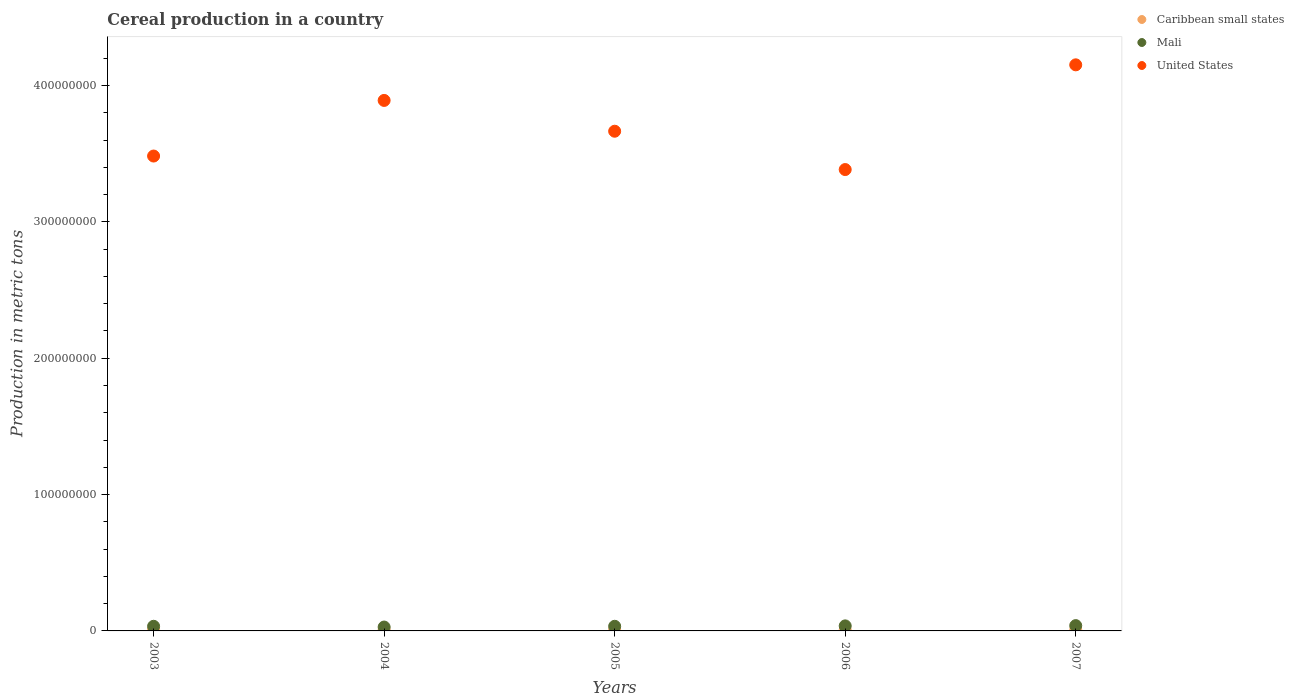How many different coloured dotlines are there?
Provide a short and direct response. 3. What is the total cereal production in United States in 2003?
Provide a short and direct response. 3.48e+08. Across all years, what is the maximum total cereal production in Caribbean small states?
Provide a short and direct response. 8.09e+05. Across all years, what is the minimum total cereal production in Caribbean small states?
Ensure brevity in your answer.  6.56e+05. In which year was the total cereal production in United States maximum?
Ensure brevity in your answer.  2007. In which year was the total cereal production in Mali minimum?
Provide a succinct answer. 2004. What is the total total cereal production in Caribbean small states in the graph?
Your response must be concise. 3.63e+06. What is the difference between the total cereal production in Caribbean small states in 2003 and that in 2004?
Provide a short and direct response. 7.12e+04. What is the difference between the total cereal production in United States in 2006 and the total cereal production in Mali in 2005?
Ensure brevity in your answer.  3.35e+08. What is the average total cereal production in United States per year?
Your answer should be very brief. 3.71e+08. In the year 2005, what is the difference between the total cereal production in Caribbean small states and total cereal production in United States?
Your answer should be very brief. -3.66e+08. In how many years, is the total cereal production in Mali greater than 280000000 metric tons?
Ensure brevity in your answer.  0. What is the ratio of the total cereal production in Mali in 2005 to that in 2006?
Make the answer very short. 0.92. Is the difference between the total cereal production in Caribbean small states in 2003 and 2006 greater than the difference between the total cereal production in United States in 2003 and 2006?
Give a very brief answer. No. What is the difference between the highest and the second highest total cereal production in United States?
Your response must be concise. 2.61e+07. What is the difference between the highest and the lowest total cereal production in Mali?
Offer a very short reply. 1.04e+06. In how many years, is the total cereal production in Caribbean small states greater than the average total cereal production in Caribbean small states taken over all years?
Your response must be concise. 2. Is the total cereal production in Mali strictly greater than the total cereal production in United States over the years?
Your response must be concise. No. How many dotlines are there?
Offer a terse response. 3. How many years are there in the graph?
Your response must be concise. 5. Does the graph contain any zero values?
Offer a terse response. No. Where does the legend appear in the graph?
Provide a short and direct response. Top right. What is the title of the graph?
Your response must be concise. Cereal production in a country. Does "Philippines" appear as one of the legend labels in the graph?
Ensure brevity in your answer.  No. What is the label or title of the X-axis?
Your answer should be compact. Years. What is the label or title of the Y-axis?
Your answer should be very brief. Production in metric tons. What is the Production in metric tons of Caribbean small states in 2003?
Provide a short and direct response. 8.09e+05. What is the Production in metric tons in Mali in 2003?
Your answer should be very brief. 3.40e+06. What is the Production in metric tons of United States in 2003?
Keep it short and to the point. 3.48e+08. What is the Production in metric tons in Caribbean small states in 2004?
Your response must be concise. 7.37e+05. What is the Production in metric tons in Mali in 2004?
Keep it short and to the point. 2.85e+06. What is the Production in metric tons of United States in 2004?
Provide a succinct answer. 3.89e+08. What is the Production in metric tons in Caribbean small states in 2005?
Keep it short and to the point. 6.56e+05. What is the Production in metric tons of Mali in 2005?
Offer a terse response. 3.40e+06. What is the Production in metric tons of United States in 2005?
Ensure brevity in your answer.  3.66e+08. What is the Production in metric tons in Caribbean small states in 2006?
Provide a short and direct response. 7.08e+05. What is the Production in metric tons of Mali in 2006?
Your answer should be very brief. 3.69e+06. What is the Production in metric tons in United States in 2006?
Offer a very short reply. 3.38e+08. What is the Production in metric tons in Caribbean small states in 2007?
Provide a succinct answer. 7.18e+05. What is the Production in metric tons in Mali in 2007?
Offer a terse response. 3.89e+06. What is the Production in metric tons in United States in 2007?
Your answer should be compact. 4.15e+08. Across all years, what is the maximum Production in metric tons of Caribbean small states?
Offer a very short reply. 8.09e+05. Across all years, what is the maximum Production in metric tons in Mali?
Offer a very short reply. 3.89e+06. Across all years, what is the maximum Production in metric tons in United States?
Ensure brevity in your answer.  4.15e+08. Across all years, what is the minimum Production in metric tons in Caribbean small states?
Your answer should be compact. 6.56e+05. Across all years, what is the minimum Production in metric tons of Mali?
Ensure brevity in your answer.  2.85e+06. Across all years, what is the minimum Production in metric tons of United States?
Offer a very short reply. 3.38e+08. What is the total Production in metric tons of Caribbean small states in the graph?
Your answer should be very brief. 3.63e+06. What is the total Production in metric tons in Mali in the graph?
Make the answer very short. 1.72e+07. What is the total Production in metric tons of United States in the graph?
Offer a very short reply. 1.86e+09. What is the difference between the Production in metric tons in Caribbean small states in 2003 and that in 2004?
Make the answer very short. 7.12e+04. What is the difference between the Production in metric tons of Mali in 2003 and that in 2004?
Your response must be concise. 5.57e+05. What is the difference between the Production in metric tons in United States in 2003 and that in 2004?
Your response must be concise. -4.08e+07. What is the difference between the Production in metric tons in Caribbean small states in 2003 and that in 2005?
Give a very brief answer. 1.52e+05. What is the difference between the Production in metric tons in Mali in 2003 and that in 2005?
Your answer should be very brief. 3594. What is the difference between the Production in metric tons in United States in 2003 and that in 2005?
Offer a very short reply. -1.82e+07. What is the difference between the Production in metric tons in Caribbean small states in 2003 and that in 2006?
Your answer should be very brief. 1.01e+05. What is the difference between the Production in metric tons of Mali in 2003 and that in 2006?
Your answer should be very brief. -2.91e+05. What is the difference between the Production in metric tons in United States in 2003 and that in 2006?
Your answer should be compact. 9.91e+06. What is the difference between the Production in metric tons of Caribbean small states in 2003 and that in 2007?
Your response must be concise. 9.00e+04. What is the difference between the Production in metric tons in Mali in 2003 and that in 2007?
Provide a short and direct response. -4.83e+05. What is the difference between the Production in metric tons of United States in 2003 and that in 2007?
Keep it short and to the point. -6.69e+07. What is the difference between the Production in metric tons in Caribbean small states in 2004 and that in 2005?
Offer a terse response. 8.09e+04. What is the difference between the Production in metric tons in Mali in 2004 and that in 2005?
Your answer should be compact. -5.54e+05. What is the difference between the Production in metric tons in United States in 2004 and that in 2005?
Your response must be concise. 2.26e+07. What is the difference between the Production in metric tons of Caribbean small states in 2004 and that in 2006?
Keep it short and to the point. 2.95e+04. What is the difference between the Production in metric tons in Mali in 2004 and that in 2006?
Make the answer very short. -8.48e+05. What is the difference between the Production in metric tons of United States in 2004 and that in 2006?
Provide a succinct answer. 5.07e+07. What is the difference between the Production in metric tons in Caribbean small states in 2004 and that in 2007?
Keep it short and to the point. 1.89e+04. What is the difference between the Production in metric tons of Mali in 2004 and that in 2007?
Provide a short and direct response. -1.04e+06. What is the difference between the Production in metric tons in United States in 2004 and that in 2007?
Offer a very short reply. -2.61e+07. What is the difference between the Production in metric tons of Caribbean small states in 2005 and that in 2006?
Ensure brevity in your answer.  -5.14e+04. What is the difference between the Production in metric tons of Mali in 2005 and that in 2006?
Offer a terse response. -2.95e+05. What is the difference between the Production in metric tons in United States in 2005 and that in 2006?
Your answer should be compact. 2.81e+07. What is the difference between the Production in metric tons in Caribbean small states in 2005 and that in 2007?
Ensure brevity in your answer.  -6.20e+04. What is the difference between the Production in metric tons of Mali in 2005 and that in 2007?
Offer a very short reply. -4.87e+05. What is the difference between the Production in metric tons of United States in 2005 and that in 2007?
Your answer should be compact. -4.87e+07. What is the difference between the Production in metric tons of Caribbean small states in 2006 and that in 2007?
Give a very brief answer. -1.06e+04. What is the difference between the Production in metric tons in Mali in 2006 and that in 2007?
Make the answer very short. -1.92e+05. What is the difference between the Production in metric tons in United States in 2006 and that in 2007?
Your answer should be compact. -7.68e+07. What is the difference between the Production in metric tons in Caribbean small states in 2003 and the Production in metric tons in Mali in 2004?
Your answer should be compact. -2.04e+06. What is the difference between the Production in metric tons of Caribbean small states in 2003 and the Production in metric tons of United States in 2004?
Your answer should be compact. -3.88e+08. What is the difference between the Production in metric tons in Mali in 2003 and the Production in metric tons in United States in 2004?
Keep it short and to the point. -3.86e+08. What is the difference between the Production in metric tons in Caribbean small states in 2003 and the Production in metric tons in Mali in 2005?
Keep it short and to the point. -2.59e+06. What is the difference between the Production in metric tons of Caribbean small states in 2003 and the Production in metric tons of United States in 2005?
Make the answer very short. -3.66e+08. What is the difference between the Production in metric tons of Mali in 2003 and the Production in metric tons of United States in 2005?
Ensure brevity in your answer.  -3.63e+08. What is the difference between the Production in metric tons of Caribbean small states in 2003 and the Production in metric tons of Mali in 2006?
Provide a short and direct response. -2.88e+06. What is the difference between the Production in metric tons in Caribbean small states in 2003 and the Production in metric tons in United States in 2006?
Your answer should be very brief. -3.38e+08. What is the difference between the Production in metric tons of Mali in 2003 and the Production in metric tons of United States in 2006?
Your answer should be compact. -3.35e+08. What is the difference between the Production in metric tons in Caribbean small states in 2003 and the Production in metric tons in Mali in 2007?
Make the answer very short. -3.08e+06. What is the difference between the Production in metric tons of Caribbean small states in 2003 and the Production in metric tons of United States in 2007?
Offer a very short reply. -4.14e+08. What is the difference between the Production in metric tons in Mali in 2003 and the Production in metric tons in United States in 2007?
Keep it short and to the point. -4.12e+08. What is the difference between the Production in metric tons in Caribbean small states in 2004 and the Production in metric tons in Mali in 2005?
Keep it short and to the point. -2.66e+06. What is the difference between the Production in metric tons in Caribbean small states in 2004 and the Production in metric tons in United States in 2005?
Your answer should be compact. -3.66e+08. What is the difference between the Production in metric tons of Mali in 2004 and the Production in metric tons of United States in 2005?
Give a very brief answer. -3.64e+08. What is the difference between the Production in metric tons of Caribbean small states in 2004 and the Production in metric tons of Mali in 2006?
Your response must be concise. -2.96e+06. What is the difference between the Production in metric tons in Caribbean small states in 2004 and the Production in metric tons in United States in 2006?
Offer a terse response. -3.38e+08. What is the difference between the Production in metric tons in Mali in 2004 and the Production in metric tons in United States in 2006?
Provide a short and direct response. -3.35e+08. What is the difference between the Production in metric tons in Caribbean small states in 2004 and the Production in metric tons in Mali in 2007?
Provide a short and direct response. -3.15e+06. What is the difference between the Production in metric tons in Caribbean small states in 2004 and the Production in metric tons in United States in 2007?
Offer a terse response. -4.14e+08. What is the difference between the Production in metric tons of Mali in 2004 and the Production in metric tons of United States in 2007?
Your answer should be very brief. -4.12e+08. What is the difference between the Production in metric tons in Caribbean small states in 2005 and the Production in metric tons in Mali in 2006?
Your answer should be very brief. -3.04e+06. What is the difference between the Production in metric tons of Caribbean small states in 2005 and the Production in metric tons of United States in 2006?
Give a very brief answer. -3.38e+08. What is the difference between the Production in metric tons in Mali in 2005 and the Production in metric tons in United States in 2006?
Give a very brief answer. -3.35e+08. What is the difference between the Production in metric tons in Caribbean small states in 2005 and the Production in metric tons in Mali in 2007?
Give a very brief answer. -3.23e+06. What is the difference between the Production in metric tons in Caribbean small states in 2005 and the Production in metric tons in United States in 2007?
Give a very brief answer. -4.14e+08. What is the difference between the Production in metric tons in Mali in 2005 and the Production in metric tons in United States in 2007?
Offer a very short reply. -4.12e+08. What is the difference between the Production in metric tons of Caribbean small states in 2006 and the Production in metric tons of Mali in 2007?
Provide a short and direct response. -3.18e+06. What is the difference between the Production in metric tons of Caribbean small states in 2006 and the Production in metric tons of United States in 2007?
Offer a very short reply. -4.14e+08. What is the difference between the Production in metric tons in Mali in 2006 and the Production in metric tons in United States in 2007?
Your answer should be very brief. -4.11e+08. What is the average Production in metric tons in Caribbean small states per year?
Your answer should be compact. 7.26e+05. What is the average Production in metric tons of Mali per year?
Ensure brevity in your answer.  3.45e+06. What is the average Production in metric tons in United States per year?
Ensure brevity in your answer.  3.71e+08. In the year 2003, what is the difference between the Production in metric tons of Caribbean small states and Production in metric tons of Mali?
Give a very brief answer. -2.59e+06. In the year 2003, what is the difference between the Production in metric tons in Caribbean small states and Production in metric tons in United States?
Your response must be concise. -3.47e+08. In the year 2003, what is the difference between the Production in metric tons in Mali and Production in metric tons in United States?
Provide a succinct answer. -3.45e+08. In the year 2004, what is the difference between the Production in metric tons of Caribbean small states and Production in metric tons of Mali?
Provide a short and direct response. -2.11e+06. In the year 2004, what is the difference between the Production in metric tons in Caribbean small states and Production in metric tons in United States?
Ensure brevity in your answer.  -3.88e+08. In the year 2004, what is the difference between the Production in metric tons of Mali and Production in metric tons of United States?
Offer a very short reply. -3.86e+08. In the year 2005, what is the difference between the Production in metric tons in Caribbean small states and Production in metric tons in Mali?
Keep it short and to the point. -2.74e+06. In the year 2005, what is the difference between the Production in metric tons in Caribbean small states and Production in metric tons in United States?
Your answer should be very brief. -3.66e+08. In the year 2005, what is the difference between the Production in metric tons of Mali and Production in metric tons of United States?
Keep it short and to the point. -3.63e+08. In the year 2006, what is the difference between the Production in metric tons of Caribbean small states and Production in metric tons of Mali?
Provide a short and direct response. -2.99e+06. In the year 2006, what is the difference between the Production in metric tons of Caribbean small states and Production in metric tons of United States?
Offer a terse response. -3.38e+08. In the year 2006, what is the difference between the Production in metric tons of Mali and Production in metric tons of United States?
Offer a terse response. -3.35e+08. In the year 2007, what is the difference between the Production in metric tons of Caribbean small states and Production in metric tons of Mali?
Ensure brevity in your answer.  -3.17e+06. In the year 2007, what is the difference between the Production in metric tons of Caribbean small states and Production in metric tons of United States?
Give a very brief answer. -4.14e+08. In the year 2007, what is the difference between the Production in metric tons of Mali and Production in metric tons of United States?
Provide a short and direct response. -4.11e+08. What is the ratio of the Production in metric tons in Caribbean small states in 2003 to that in 2004?
Give a very brief answer. 1.1. What is the ratio of the Production in metric tons in Mali in 2003 to that in 2004?
Keep it short and to the point. 1.2. What is the ratio of the Production in metric tons in United States in 2003 to that in 2004?
Provide a short and direct response. 0.9. What is the ratio of the Production in metric tons of Caribbean small states in 2003 to that in 2005?
Provide a short and direct response. 1.23. What is the ratio of the Production in metric tons of Mali in 2003 to that in 2005?
Provide a succinct answer. 1. What is the ratio of the Production in metric tons in United States in 2003 to that in 2005?
Your response must be concise. 0.95. What is the ratio of the Production in metric tons of Caribbean small states in 2003 to that in 2006?
Your answer should be very brief. 1.14. What is the ratio of the Production in metric tons in Mali in 2003 to that in 2006?
Your answer should be very brief. 0.92. What is the ratio of the Production in metric tons in United States in 2003 to that in 2006?
Make the answer very short. 1.03. What is the ratio of the Production in metric tons of Caribbean small states in 2003 to that in 2007?
Your answer should be compact. 1.13. What is the ratio of the Production in metric tons of Mali in 2003 to that in 2007?
Make the answer very short. 0.88. What is the ratio of the Production in metric tons in United States in 2003 to that in 2007?
Your answer should be very brief. 0.84. What is the ratio of the Production in metric tons of Caribbean small states in 2004 to that in 2005?
Offer a terse response. 1.12. What is the ratio of the Production in metric tons in Mali in 2004 to that in 2005?
Provide a short and direct response. 0.84. What is the ratio of the Production in metric tons in United States in 2004 to that in 2005?
Your response must be concise. 1.06. What is the ratio of the Production in metric tons in Caribbean small states in 2004 to that in 2006?
Give a very brief answer. 1.04. What is the ratio of the Production in metric tons of Mali in 2004 to that in 2006?
Keep it short and to the point. 0.77. What is the ratio of the Production in metric tons in United States in 2004 to that in 2006?
Give a very brief answer. 1.15. What is the ratio of the Production in metric tons of Caribbean small states in 2004 to that in 2007?
Your answer should be compact. 1.03. What is the ratio of the Production in metric tons in Mali in 2004 to that in 2007?
Keep it short and to the point. 0.73. What is the ratio of the Production in metric tons in United States in 2004 to that in 2007?
Offer a terse response. 0.94. What is the ratio of the Production in metric tons in Caribbean small states in 2005 to that in 2006?
Provide a succinct answer. 0.93. What is the ratio of the Production in metric tons of Mali in 2005 to that in 2006?
Your response must be concise. 0.92. What is the ratio of the Production in metric tons of United States in 2005 to that in 2006?
Keep it short and to the point. 1.08. What is the ratio of the Production in metric tons in Caribbean small states in 2005 to that in 2007?
Provide a succinct answer. 0.91. What is the ratio of the Production in metric tons of Mali in 2005 to that in 2007?
Offer a terse response. 0.87. What is the ratio of the Production in metric tons in United States in 2005 to that in 2007?
Make the answer very short. 0.88. What is the ratio of the Production in metric tons of Caribbean small states in 2006 to that in 2007?
Your answer should be very brief. 0.99. What is the ratio of the Production in metric tons of Mali in 2006 to that in 2007?
Provide a succinct answer. 0.95. What is the ratio of the Production in metric tons in United States in 2006 to that in 2007?
Ensure brevity in your answer.  0.81. What is the difference between the highest and the second highest Production in metric tons of Caribbean small states?
Provide a succinct answer. 7.12e+04. What is the difference between the highest and the second highest Production in metric tons of Mali?
Keep it short and to the point. 1.92e+05. What is the difference between the highest and the second highest Production in metric tons in United States?
Ensure brevity in your answer.  2.61e+07. What is the difference between the highest and the lowest Production in metric tons of Caribbean small states?
Offer a terse response. 1.52e+05. What is the difference between the highest and the lowest Production in metric tons in Mali?
Offer a terse response. 1.04e+06. What is the difference between the highest and the lowest Production in metric tons in United States?
Give a very brief answer. 7.68e+07. 